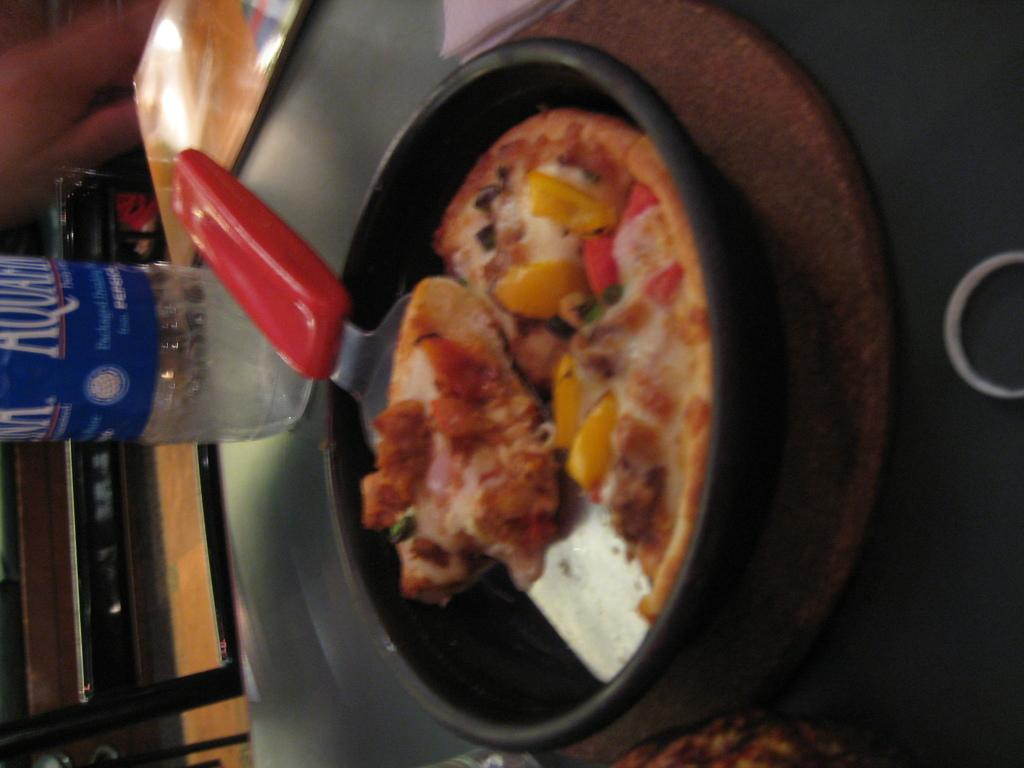What type of food is shown in the image? There is a pizza in the image. How is the pizza being held or contained? The pizza is placed in a pan. What tool is present for cutting the pizza? There is a pizza cutter in the image. Where are the pizza, pan, and pizza cutter located? They are placed on a table. What other items can be seen on the table? There are cards and a bottle on the table. Is there any beverage container visible? Yes, there is a cup on the table. What type of rifle is being used to cut the pizza in the image? There is no rifle present in the image; the pizza is being cut with a pizza cutter. How does the account balance relate to the pizza in the image? There is no mention of an account balance in the image; it features a pizza, pan, pizza cutter, table, cards, bottle, and cup. 